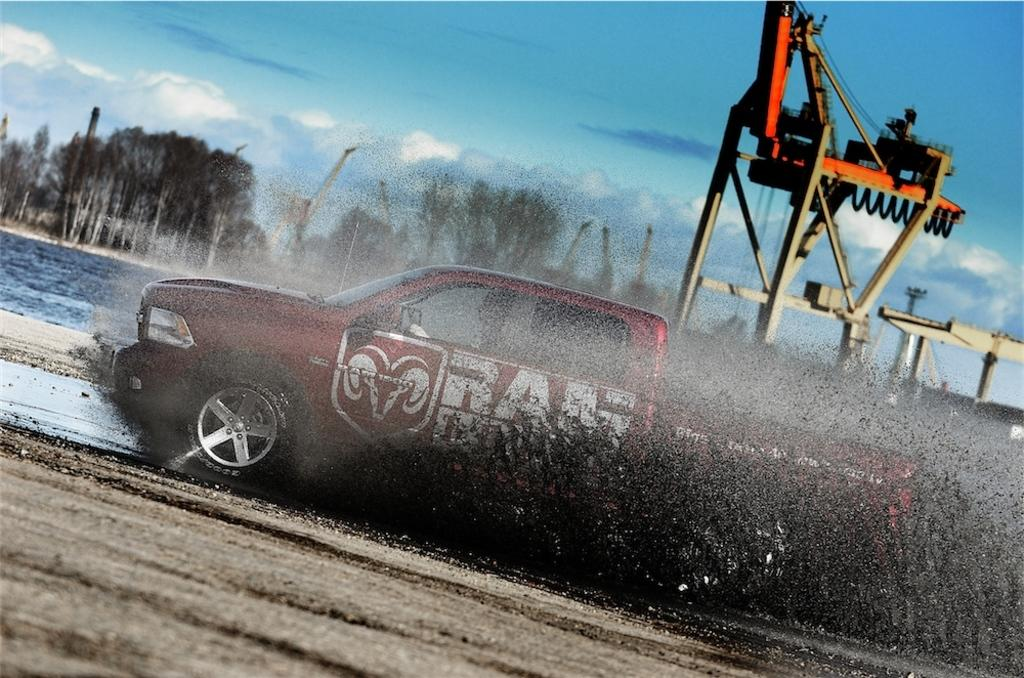What type of vehicle is in the image? There is a vehicle in the image, but the specific type is not mentioned. What other large object is present in the image? There is a crane in the image. What type of natural vegetation can be seen in the image? There are trees in the image. What is visible in the background of the image? The sky is visible in the image. What type of boot is hanging from the crane in the image? There is no boot present in the image; it only features a vehicle, a crane, trees, and the sky. 